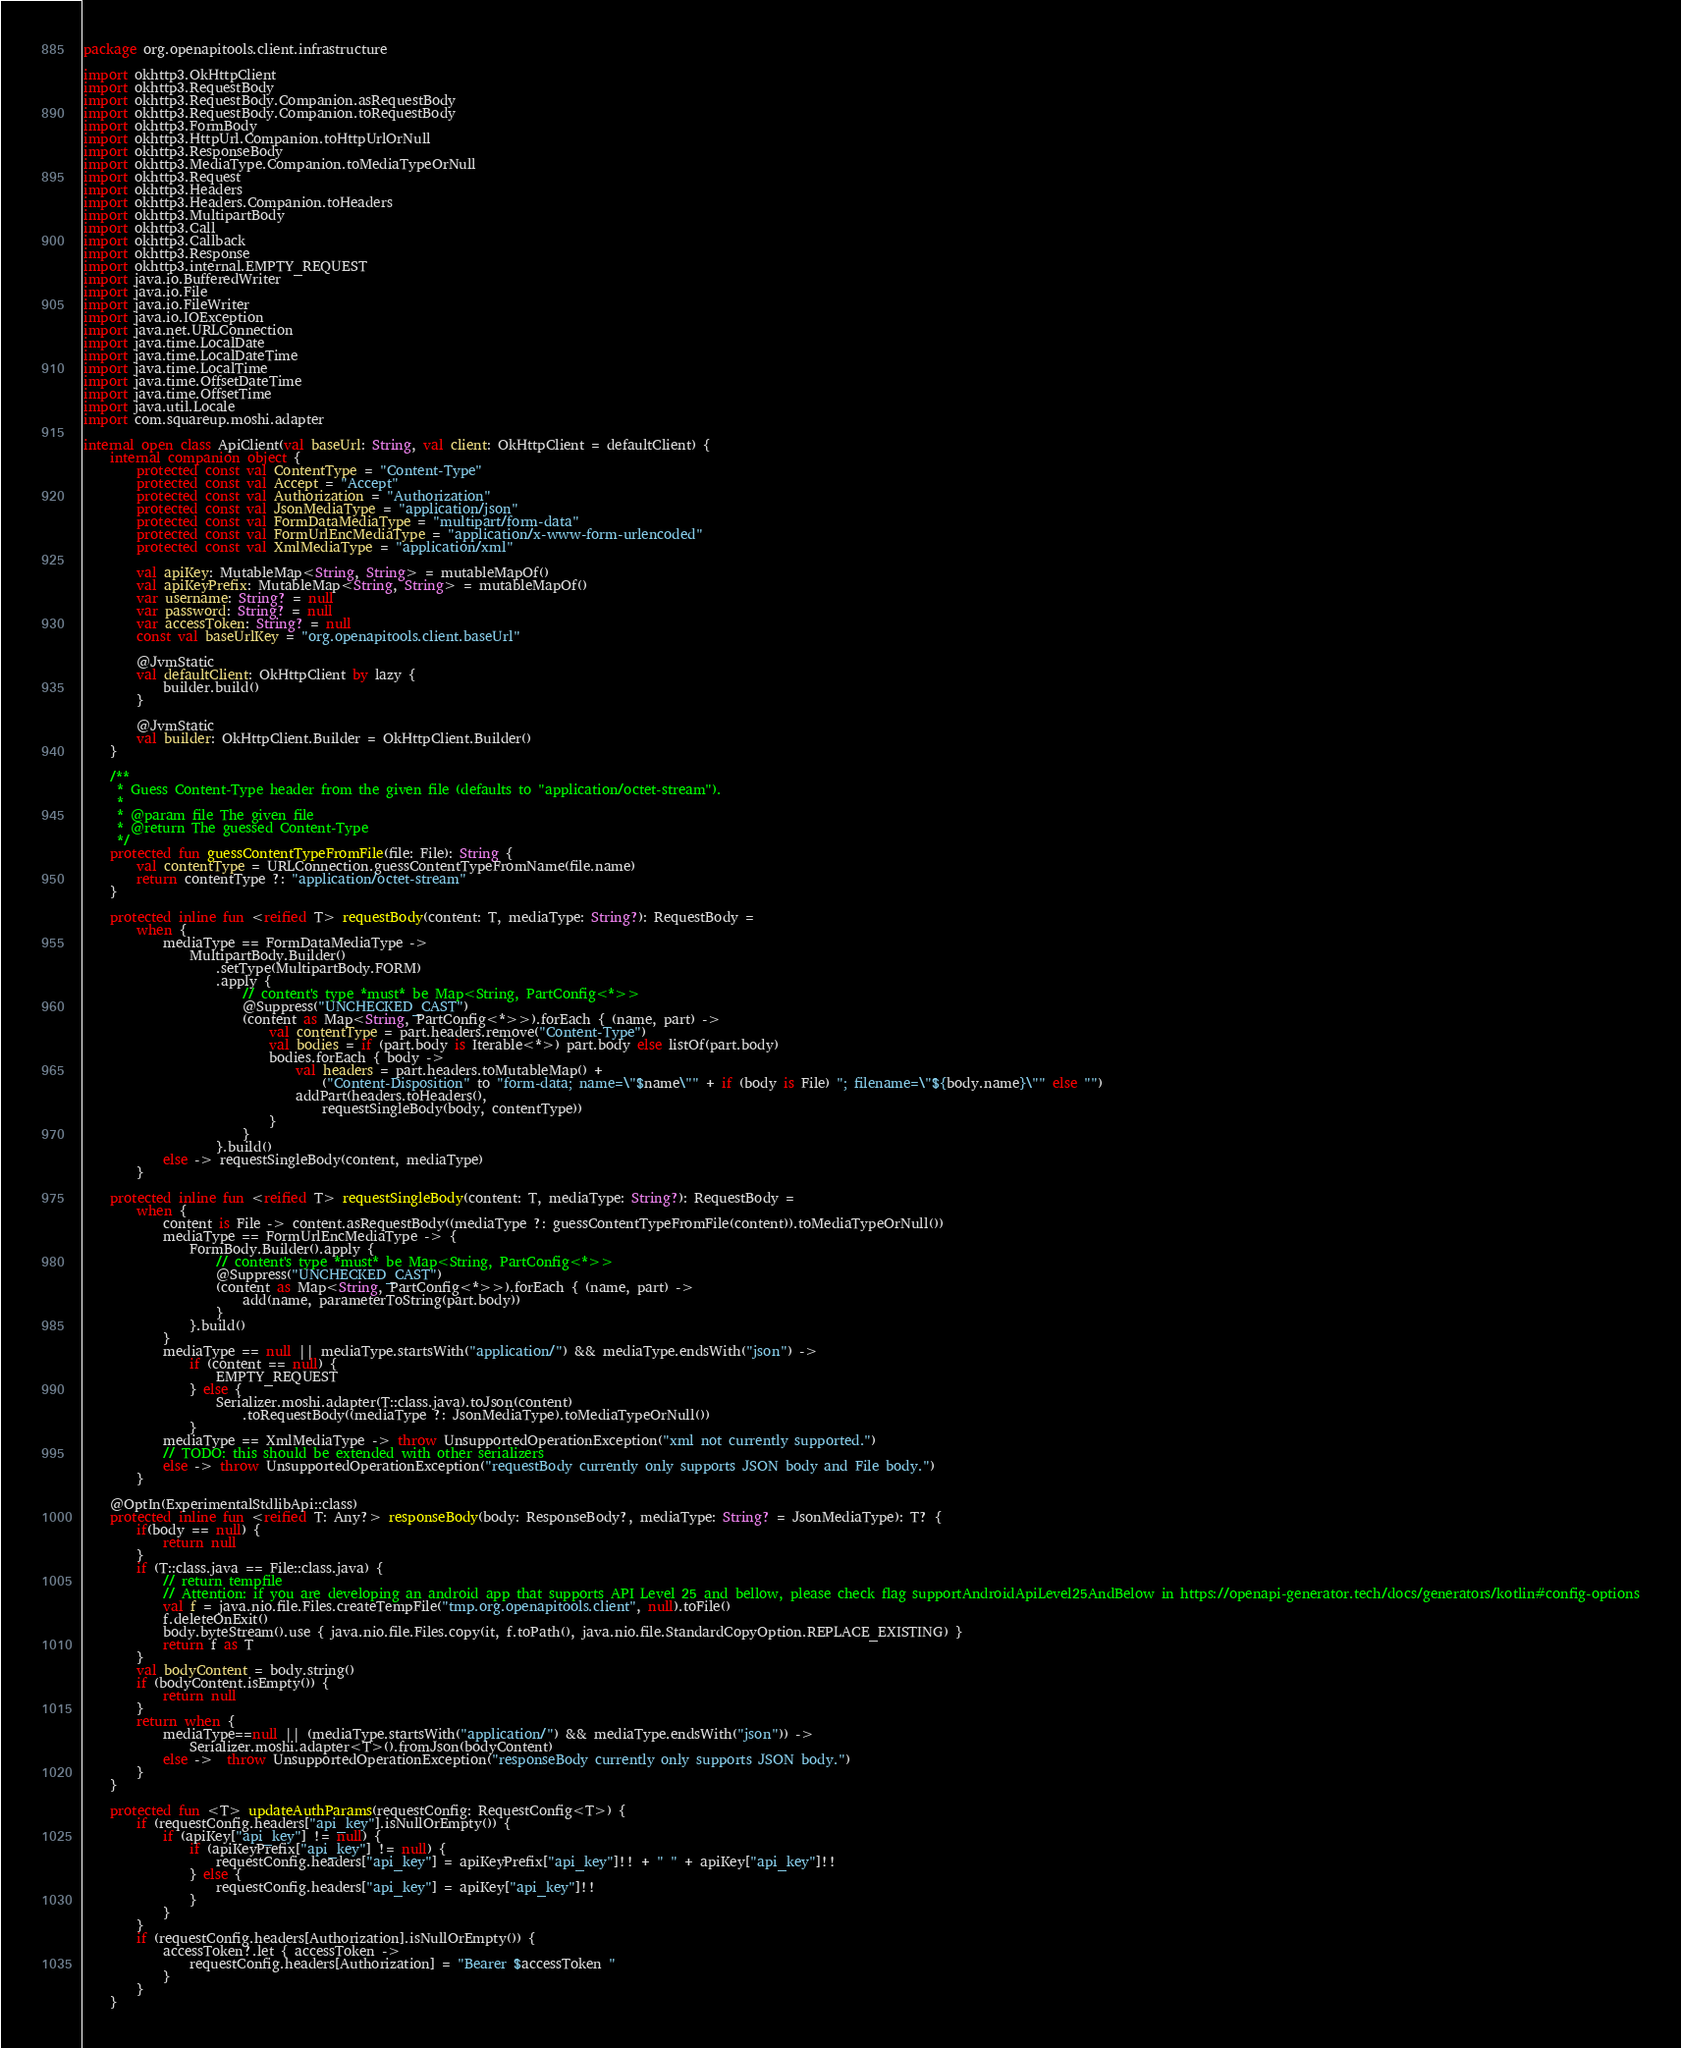Convert code to text. <code><loc_0><loc_0><loc_500><loc_500><_Kotlin_>package org.openapitools.client.infrastructure

import okhttp3.OkHttpClient
import okhttp3.RequestBody
import okhttp3.RequestBody.Companion.asRequestBody
import okhttp3.RequestBody.Companion.toRequestBody
import okhttp3.FormBody
import okhttp3.HttpUrl.Companion.toHttpUrlOrNull
import okhttp3.ResponseBody
import okhttp3.MediaType.Companion.toMediaTypeOrNull
import okhttp3.Request
import okhttp3.Headers
import okhttp3.Headers.Companion.toHeaders
import okhttp3.MultipartBody
import okhttp3.Call
import okhttp3.Callback
import okhttp3.Response
import okhttp3.internal.EMPTY_REQUEST
import java.io.BufferedWriter
import java.io.File
import java.io.FileWriter
import java.io.IOException
import java.net.URLConnection
import java.time.LocalDate
import java.time.LocalDateTime
import java.time.LocalTime
import java.time.OffsetDateTime
import java.time.OffsetTime
import java.util.Locale
import com.squareup.moshi.adapter

internal open class ApiClient(val baseUrl: String, val client: OkHttpClient = defaultClient) {
    internal companion object {
        protected const val ContentType = "Content-Type"
        protected const val Accept = "Accept"
        protected const val Authorization = "Authorization"
        protected const val JsonMediaType = "application/json"
        protected const val FormDataMediaType = "multipart/form-data"
        protected const val FormUrlEncMediaType = "application/x-www-form-urlencoded"
        protected const val XmlMediaType = "application/xml"

        val apiKey: MutableMap<String, String> = mutableMapOf()
        val apiKeyPrefix: MutableMap<String, String> = mutableMapOf()
        var username: String? = null
        var password: String? = null
        var accessToken: String? = null
        const val baseUrlKey = "org.openapitools.client.baseUrl"

        @JvmStatic
        val defaultClient: OkHttpClient by lazy {
            builder.build()
        }

        @JvmStatic
        val builder: OkHttpClient.Builder = OkHttpClient.Builder()
    }

    /**
     * Guess Content-Type header from the given file (defaults to "application/octet-stream").
     *
     * @param file The given file
     * @return The guessed Content-Type
     */
    protected fun guessContentTypeFromFile(file: File): String {
        val contentType = URLConnection.guessContentTypeFromName(file.name)
        return contentType ?: "application/octet-stream"
    }

    protected inline fun <reified T> requestBody(content: T, mediaType: String?): RequestBody =
        when {
            mediaType == FormDataMediaType ->
                MultipartBody.Builder()
                    .setType(MultipartBody.FORM)
                    .apply {
                        // content's type *must* be Map<String, PartConfig<*>>
                        @Suppress("UNCHECKED_CAST")
                        (content as Map<String, PartConfig<*>>).forEach { (name, part) ->
                            val contentType = part.headers.remove("Content-Type")
                            val bodies = if (part.body is Iterable<*>) part.body else listOf(part.body)
                            bodies.forEach { body ->
                                val headers = part.headers.toMutableMap() +
                                    ("Content-Disposition" to "form-data; name=\"$name\"" + if (body is File) "; filename=\"${body.name}\"" else "")
                                addPart(headers.toHeaders(),
                                    requestSingleBody(body, contentType))
                            }
                        }
                    }.build()
            else -> requestSingleBody(content, mediaType)
        }

    protected inline fun <reified T> requestSingleBody(content: T, mediaType: String?): RequestBody =
        when {
            content is File -> content.asRequestBody((mediaType ?: guessContentTypeFromFile(content)).toMediaTypeOrNull())
            mediaType == FormUrlEncMediaType -> {
                FormBody.Builder().apply {
                    // content's type *must* be Map<String, PartConfig<*>>
                    @Suppress("UNCHECKED_CAST")
                    (content as Map<String, PartConfig<*>>).forEach { (name, part) ->
                        add(name, parameterToString(part.body))
                    }
                }.build()
            }
            mediaType == null || mediaType.startsWith("application/") && mediaType.endsWith("json") ->
                if (content == null) {
                    EMPTY_REQUEST
                } else {
                    Serializer.moshi.adapter(T::class.java).toJson(content)
                        .toRequestBody((mediaType ?: JsonMediaType).toMediaTypeOrNull())
                }
            mediaType == XmlMediaType -> throw UnsupportedOperationException("xml not currently supported.")
            // TODO: this should be extended with other serializers
            else -> throw UnsupportedOperationException("requestBody currently only supports JSON body and File body.")
        }

    @OptIn(ExperimentalStdlibApi::class)
    protected inline fun <reified T: Any?> responseBody(body: ResponseBody?, mediaType: String? = JsonMediaType): T? {
        if(body == null) {
            return null
        }
        if (T::class.java == File::class.java) {
            // return tempfile
            // Attention: if you are developing an android app that supports API Level 25 and bellow, please check flag supportAndroidApiLevel25AndBelow in https://openapi-generator.tech/docs/generators/kotlin#config-options
            val f = java.nio.file.Files.createTempFile("tmp.org.openapitools.client", null).toFile()
            f.deleteOnExit()
            body.byteStream().use { java.nio.file.Files.copy(it, f.toPath(), java.nio.file.StandardCopyOption.REPLACE_EXISTING) }
            return f as T
        }
        val bodyContent = body.string()
        if (bodyContent.isEmpty()) {
            return null
        }
        return when {
            mediaType==null || (mediaType.startsWith("application/") && mediaType.endsWith("json")) ->
                Serializer.moshi.adapter<T>().fromJson(bodyContent)
            else ->  throw UnsupportedOperationException("responseBody currently only supports JSON body.")
        }
    }

    protected fun <T> updateAuthParams(requestConfig: RequestConfig<T>) {
        if (requestConfig.headers["api_key"].isNullOrEmpty()) {
            if (apiKey["api_key"] != null) {
                if (apiKeyPrefix["api_key"] != null) {
                    requestConfig.headers["api_key"] = apiKeyPrefix["api_key"]!! + " " + apiKey["api_key"]!!
                } else {
                    requestConfig.headers["api_key"] = apiKey["api_key"]!!
                }
            }
        }
        if (requestConfig.headers[Authorization].isNullOrEmpty()) {
            accessToken?.let { accessToken ->
                requestConfig.headers[Authorization] = "Bearer $accessToken "
            }
        }
    }
</code> 